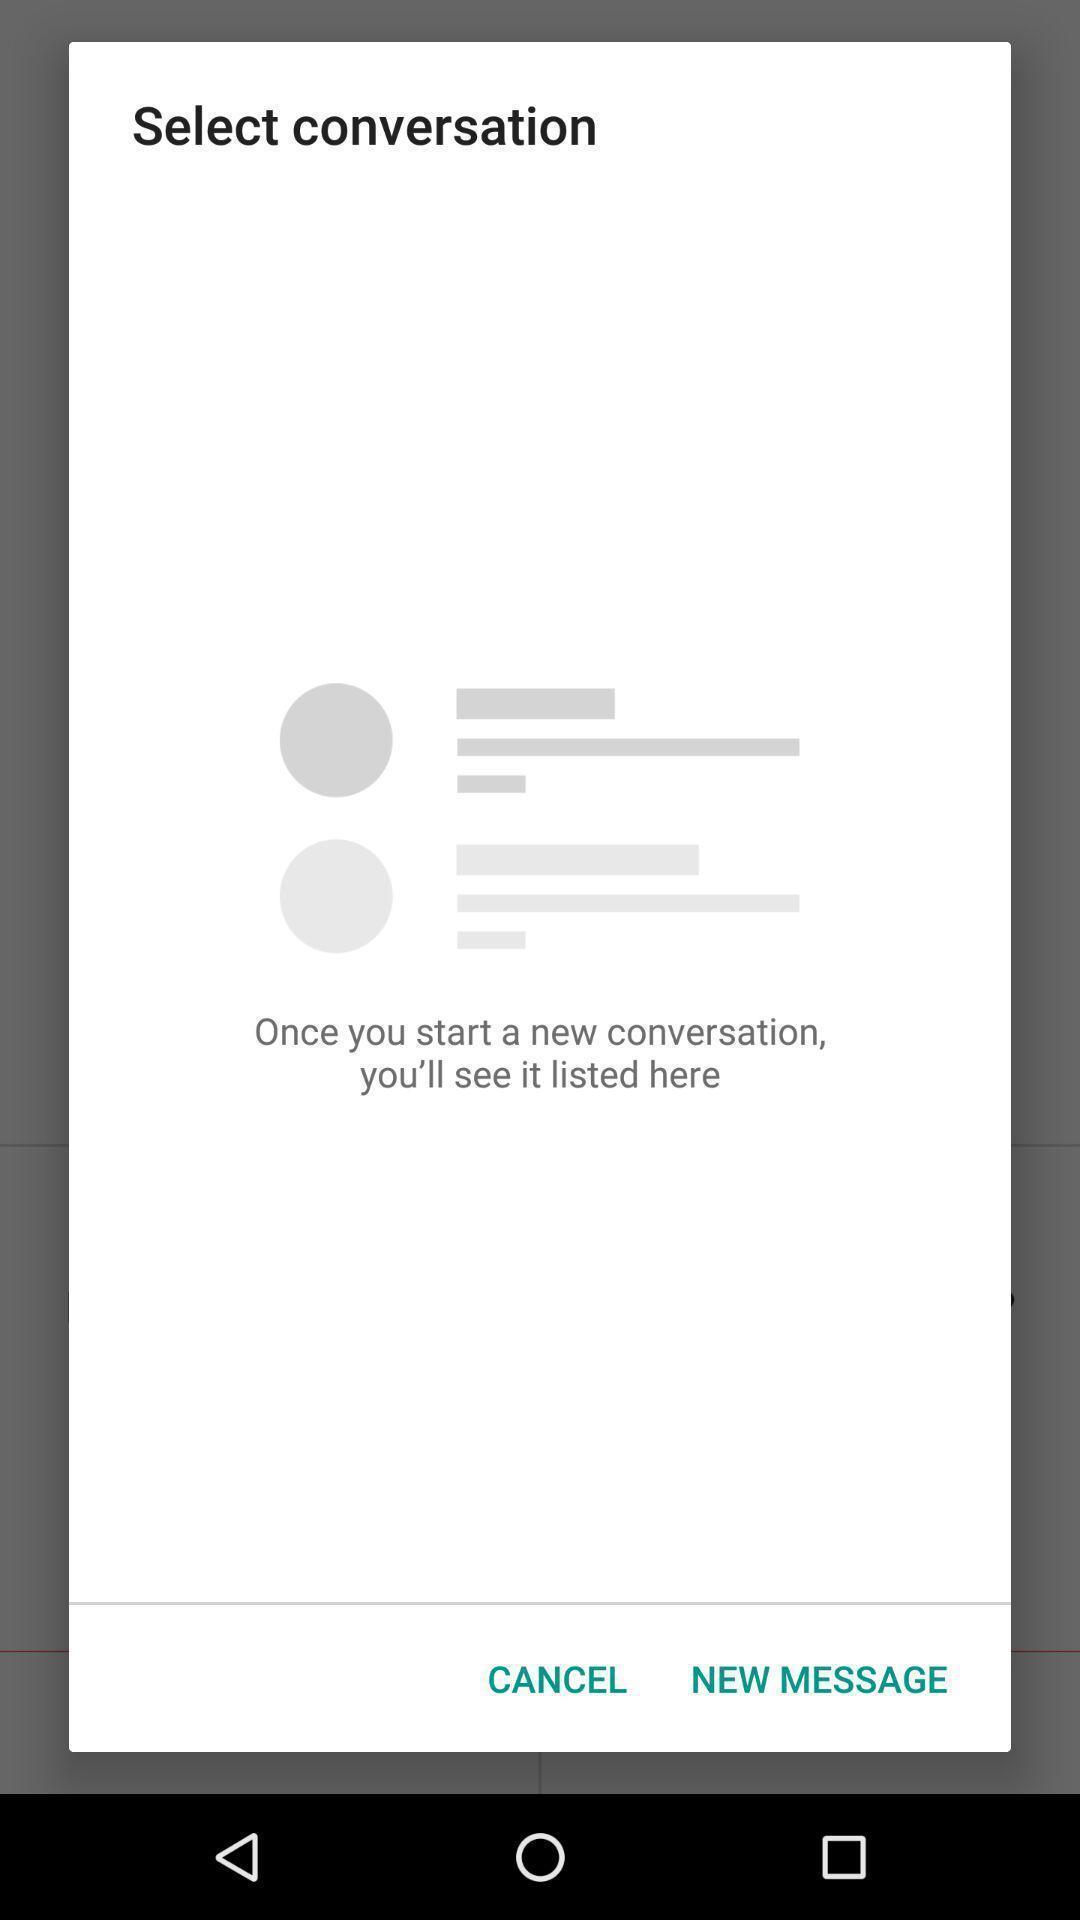Describe the content in this image. Popup showing about the conversation. 